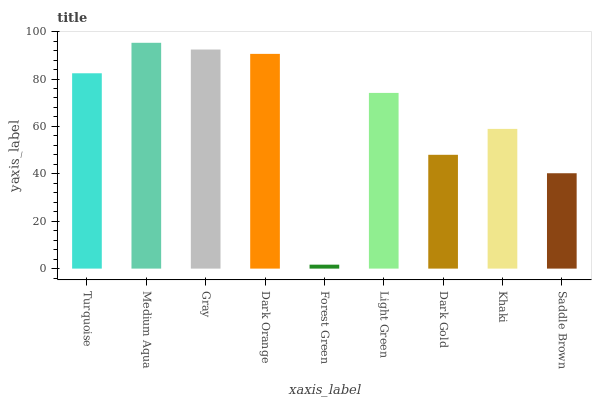Is Forest Green the minimum?
Answer yes or no. Yes. Is Medium Aqua the maximum?
Answer yes or no. Yes. Is Gray the minimum?
Answer yes or no. No. Is Gray the maximum?
Answer yes or no. No. Is Medium Aqua greater than Gray?
Answer yes or no. Yes. Is Gray less than Medium Aqua?
Answer yes or no. Yes. Is Gray greater than Medium Aqua?
Answer yes or no. No. Is Medium Aqua less than Gray?
Answer yes or no. No. Is Light Green the high median?
Answer yes or no. Yes. Is Light Green the low median?
Answer yes or no. Yes. Is Turquoise the high median?
Answer yes or no. No. Is Medium Aqua the low median?
Answer yes or no. No. 